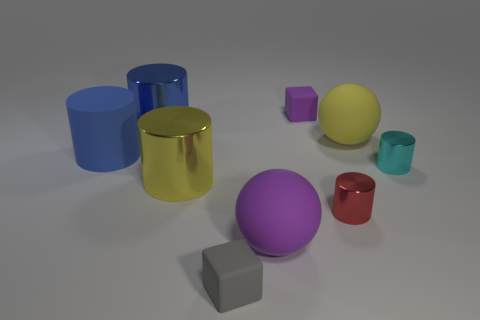Subtract all small cylinders. How many cylinders are left? 3 Subtract all purple cubes. How many blue cylinders are left? 2 Add 1 purple matte cylinders. How many objects exist? 10 Subtract all yellow cylinders. How many cylinders are left? 4 Add 6 large rubber balls. How many large rubber balls are left? 8 Add 9 large yellow matte objects. How many large yellow matte objects exist? 10 Subtract 1 cyan cylinders. How many objects are left? 8 Subtract all balls. How many objects are left? 7 Subtract all brown balls. Subtract all blue cubes. How many balls are left? 2 Subtract all large yellow metal cylinders. Subtract all large spheres. How many objects are left? 6 